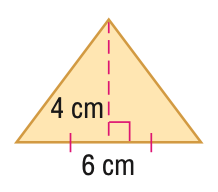Answer the mathemtical geometry problem and directly provide the correct option letter.
Question: Find the perimeter or circumference of the figure. Round to the nearest tenth.
Choices: A: 12 B: 14 C: 16 D: 18 C 